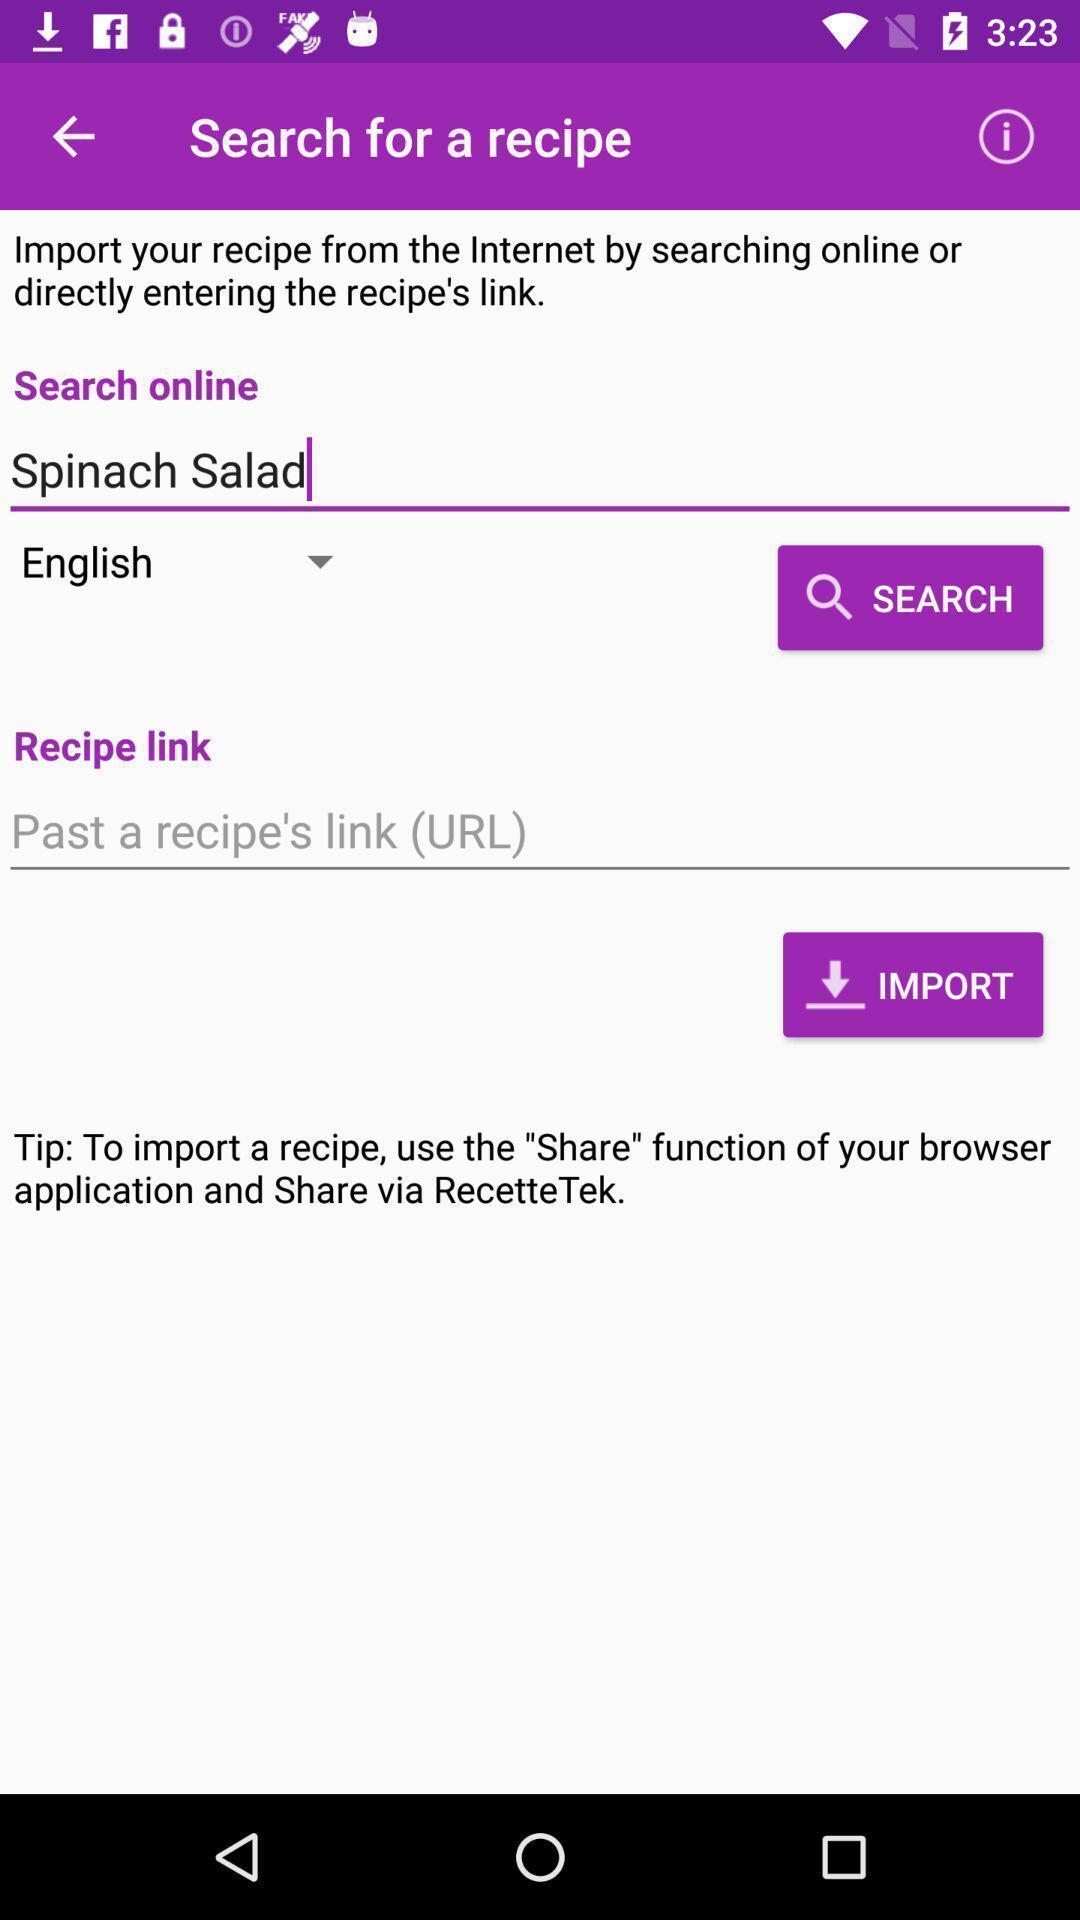Describe the visual elements of this screenshot. Search page to search a recipe in recipe app. 